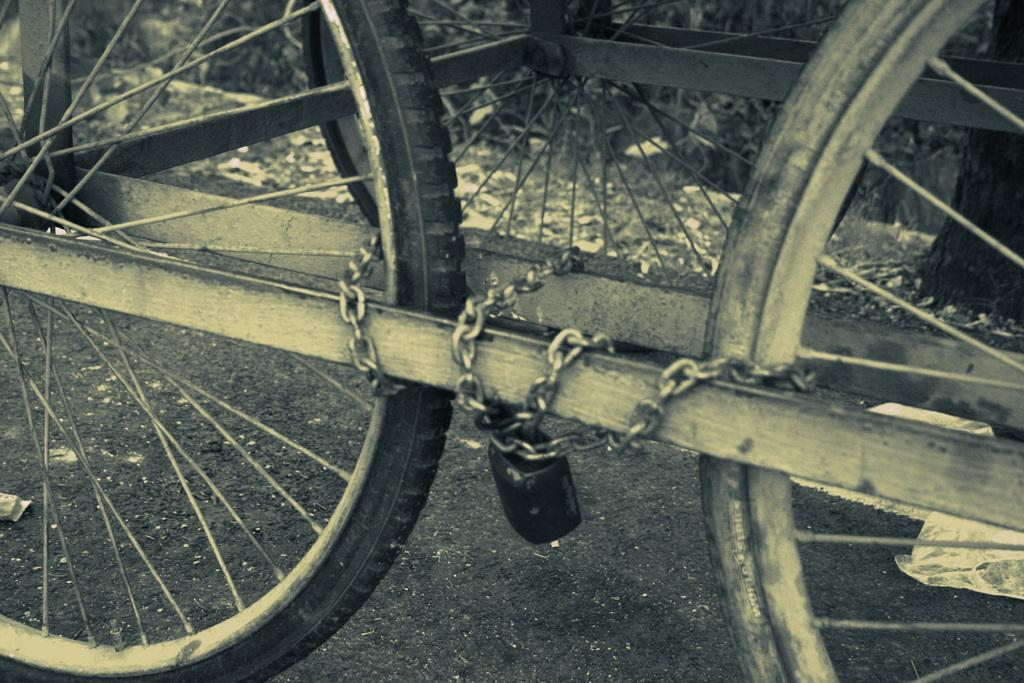What objects are present in the image that have wheels? There are: There are three wheels in the image. How are the wheels connected to each other? The wheels are tied with a chain. Is the chain securing the wheels in any way? Yes, the chain is locked. What else can be seen on the floor in the image? There are plastic covers on the floor. How many lumber pieces are being carried by the deer in the image? There are no lumber pieces or deer present in the image. 